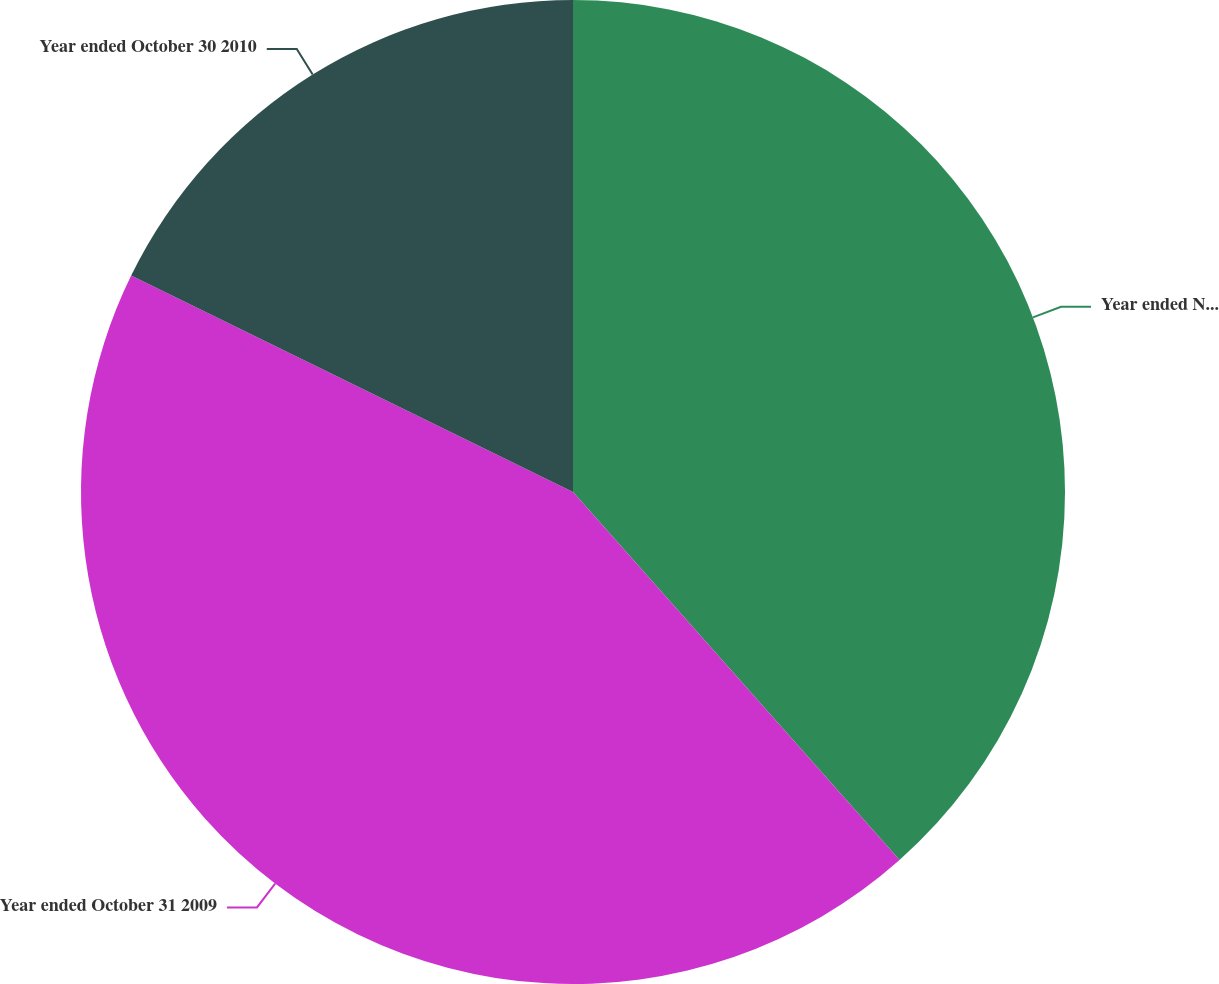Convert chart to OTSL. <chart><loc_0><loc_0><loc_500><loc_500><pie_chart><fcel>Year ended November 1 2008<fcel>Year ended October 31 2009<fcel>Year ended October 30 2010<nl><fcel>38.45%<fcel>43.8%<fcel>17.75%<nl></chart> 